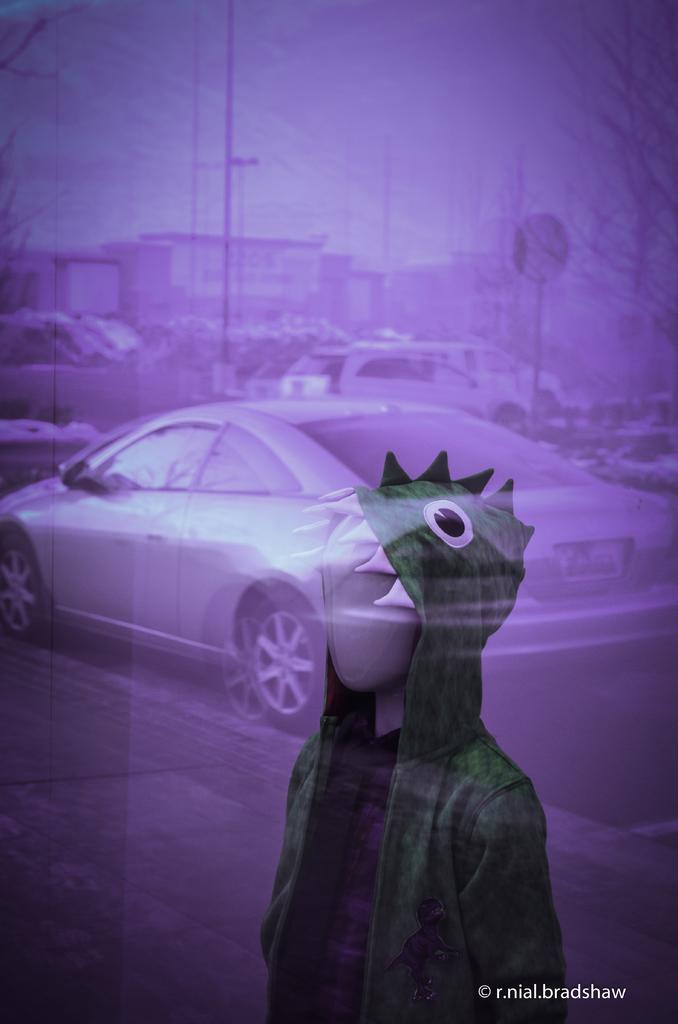What is the main subject in the foreground of the image? There is a mannequin with a dress in the image. What can be seen in the background of the image? There are vehicles, poles, trees, buildings, and the sky visible in the background of the image. What type of protest is taking place in the image? There is no protest present in the image; it features a mannequin with a dress and various background elements. Can you see the moon in the image? The moon is not visible in the image; only the sky is visible in the background. 